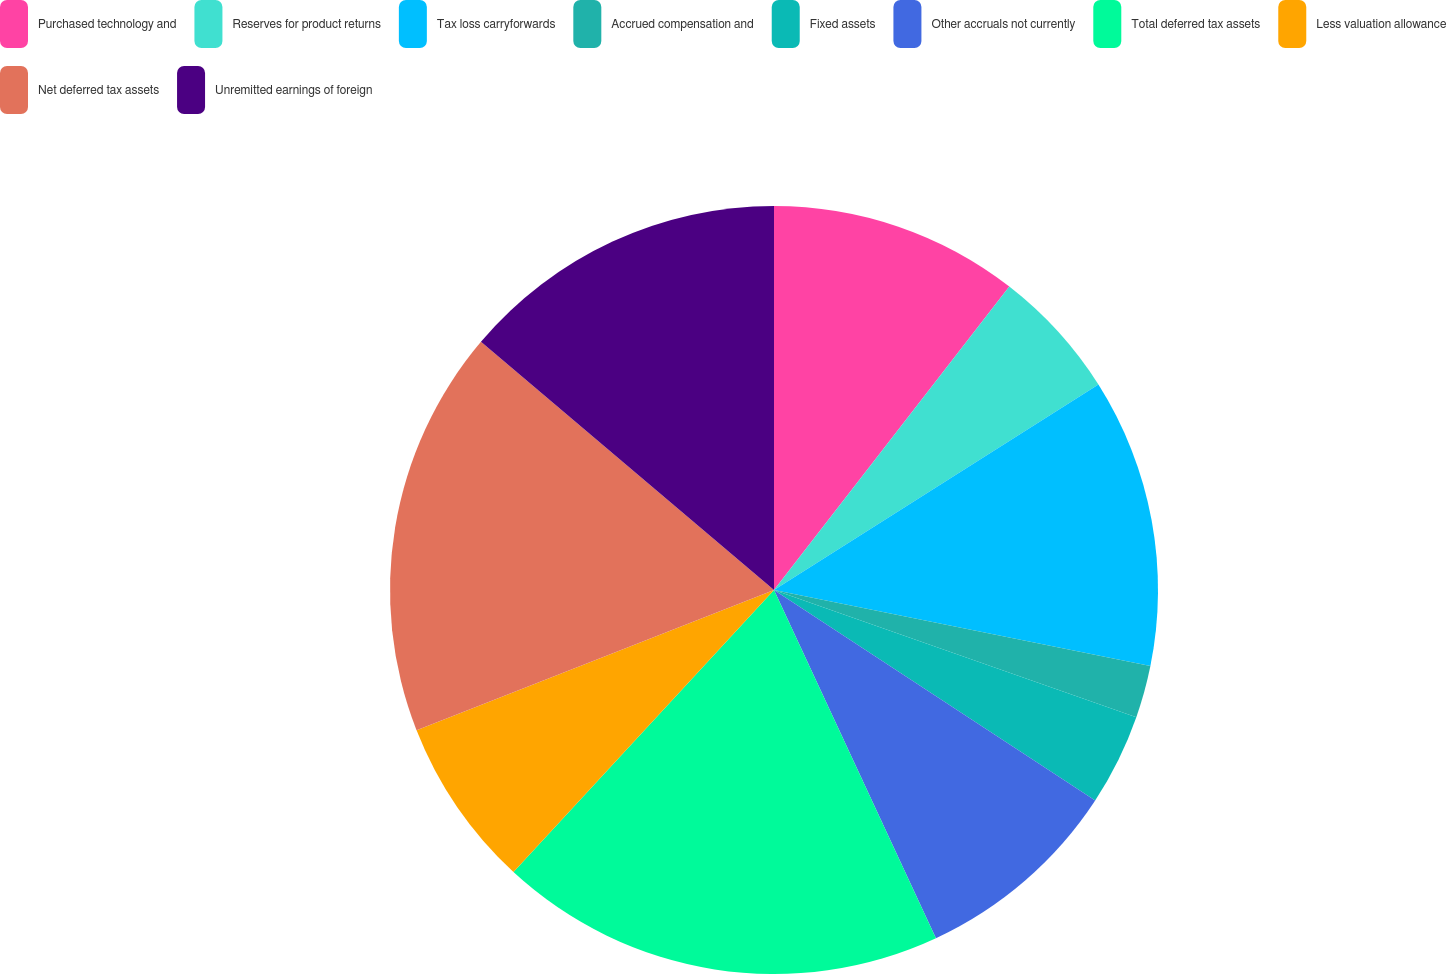Convert chart. <chart><loc_0><loc_0><loc_500><loc_500><pie_chart><fcel>Purchased technology and<fcel>Reserves for product returns<fcel>Tax loss carryforwards<fcel>Accrued compensation and<fcel>Fixed assets<fcel>Other accruals not currently<fcel>Total deferred tax assets<fcel>Less valuation allowance<fcel>Net deferred tax assets<fcel>Unremitted earnings of foreign<nl><fcel>10.5%<fcel>5.52%<fcel>12.16%<fcel>2.2%<fcel>3.86%<fcel>8.84%<fcel>18.8%<fcel>7.18%<fcel>17.14%<fcel>13.82%<nl></chart> 